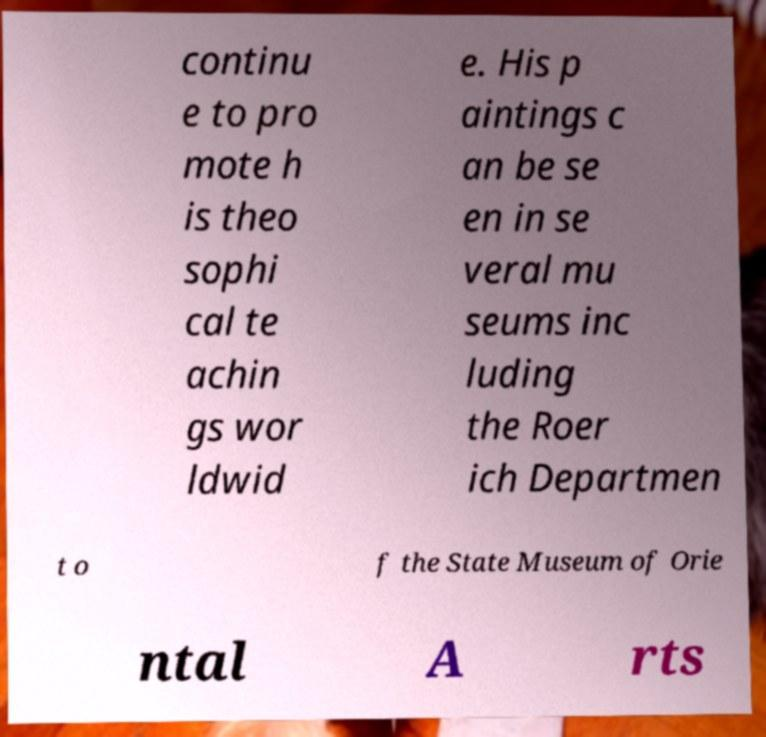Please identify and transcribe the text found in this image. continu e to pro mote h is theo sophi cal te achin gs wor ldwid e. His p aintings c an be se en in se veral mu seums inc luding the Roer ich Departmen t o f the State Museum of Orie ntal A rts 